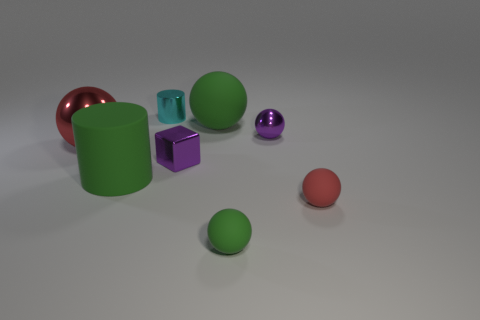Subtract all purple spheres. How many spheres are left? 4 Subtract all small metal balls. How many balls are left? 4 Subtract all cyan cubes. Subtract all yellow cylinders. How many cubes are left? 1 Add 1 green matte balls. How many objects exist? 9 Subtract all cubes. How many objects are left? 7 Subtract all big objects. Subtract all big matte cylinders. How many objects are left? 4 Add 5 red matte things. How many red matte things are left? 6 Add 7 small cyan metal cylinders. How many small cyan metal cylinders exist? 8 Subtract 0 yellow balls. How many objects are left? 8 